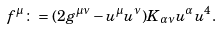Convert formula to latex. <formula><loc_0><loc_0><loc_500><loc_500>f ^ { \mu } \colon = ( 2 g ^ { \mu \nu } - u ^ { \mu } u ^ { \nu } ) K _ { \alpha \nu } u ^ { \alpha } u ^ { 4 } .</formula> 